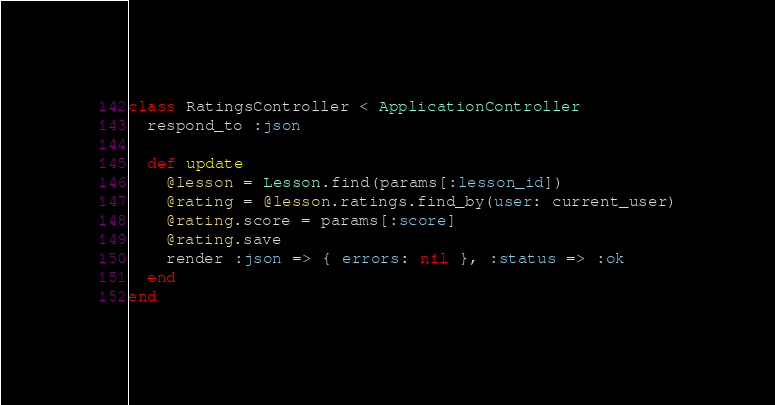Convert code to text. <code><loc_0><loc_0><loc_500><loc_500><_Ruby_>class RatingsController < ApplicationController
  respond_to :json

  def update
    @lesson = Lesson.find(params[:lesson_id])
    @rating = @lesson.ratings.find_by(user: current_user)
    @rating.score = params[:score]
    @rating.save
    render :json => { errors: nil }, :status => :ok
  end
end
</code> 